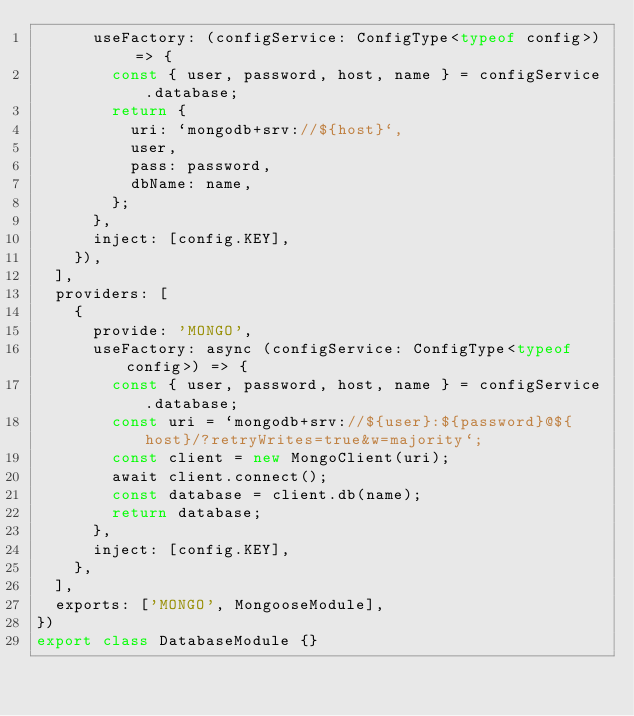Convert code to text. <code><loc_0><loc_0><loc_500><loc_500><_TypeScript_>      useFactory: (configService: ConfigType<typeof config>) => {
        const { user, password, host, name } = configService.database;
        return {
          uri: `mongodb+srv://${host}`,
          user,
          pass: password,
          dbName: name,
        };
      },
      inject: [config.KEY],
    }),
  ],
  providers: [
    {
      provide: 'MONGO',
      useFactory: async (configService: ConfigType<typeof config>) => {
        const { user, password, host, name } = configService.database;
        const uri = `mongodb+srv://${user}:${password}@${host}/?retryWrites=true&w=majority`;
        const client = new MongoClient(uri);
        await client.connect();
        const database = client.db(name);
        return database;
      },
      inject: [config.KEY],
    },
  ],
  exports: ['MONGO', MongooseModule],
})
export class DatabaseModule {}
</code> 